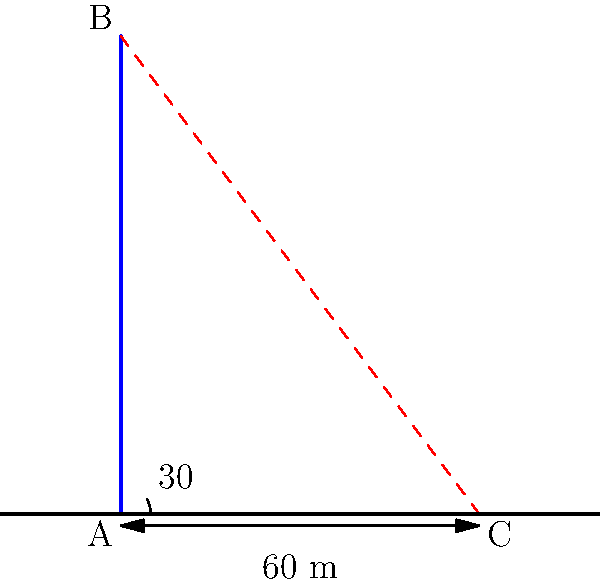In the early 20th century, architects often used shadow calculations to estimate building heights. Given a skyscraper casts a 60-meter shadow when the sun's angle of elevation is 30°, what is the height of the skyscraper? To solve this problem, we'll use trigonometry, specifically the tangent function. Let's break it down step-by-step:

1) In a right triangle, tangent of an angle is the ratio of the opposite side to the adjacent side.

2) In our case:
   - The angle of elevation is 30°
   - The adjacent side (shadow length) is 60 meters
   - The opposite side (building height) is what we're looking for

3) Let's call the building height $h$. We can write the equation:

   $\tan(30°) = \frac{h}{60}$

4) We know that $\tan(30°) = \frac{1}{\sqrt{3}}$, so we can rewrite the equation:

   $\frac{1}{\sqrt{3}} = \frac{h}{60}$

5) Multiply both sides by 60:

   $\frac{60}{\sqrt{3}} = h$

6) Simplify:

   $h = 60 \cdot \frac{\sqrt{3}}{3} = 20\sqrt{3}$ meters

7) If we want a decimal approximation:

   $20\sqrt{3} \approx 34.64$ meters

Thus, the height of the skyscraper is $20\sqrt{3}$ meters or approximately 34.64 meters.
Answer: $20\sqrt{3}$ meters 